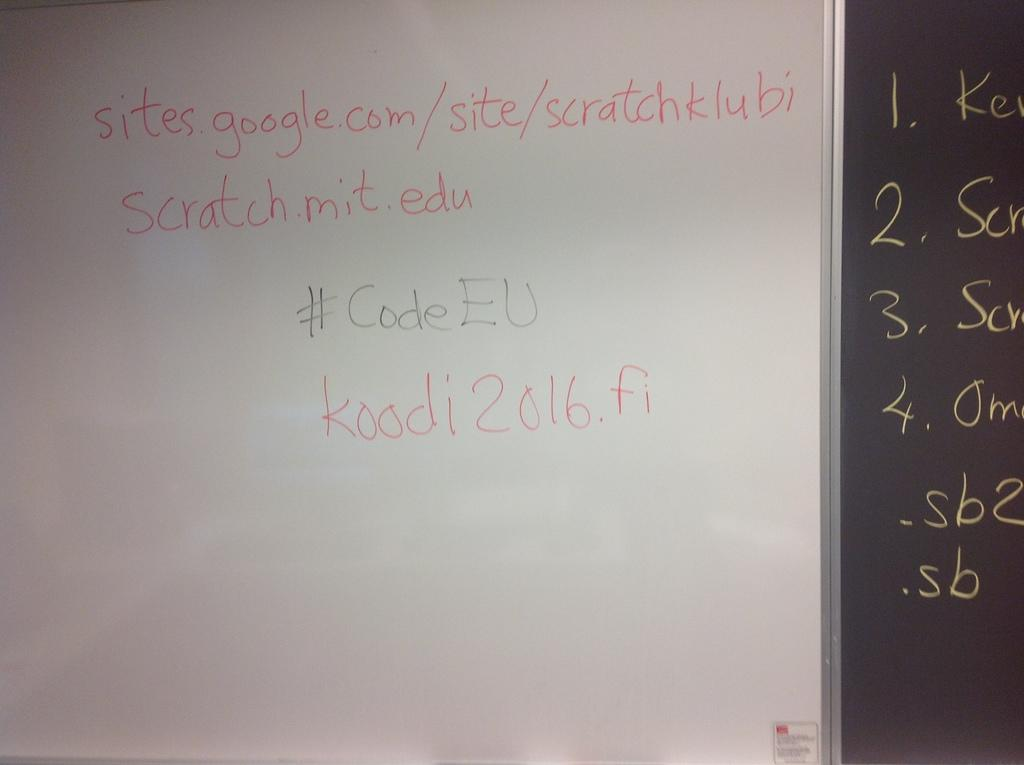Provide a one-sentence caption for the provided image. a piece of code about a google site with its login code. 